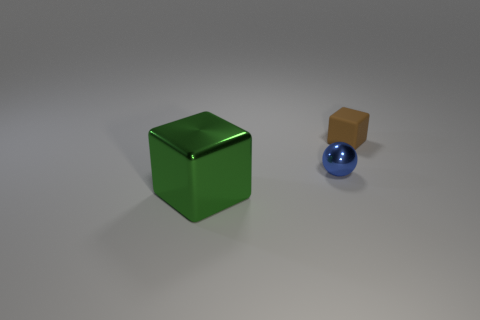Add 2 small brown cylinders. How many objects exist? 5 Subtract all balls. How many objects are left? 2 Subtract all large brown metal cubes. Subtract all brown matte blocks. How many objects are left? 2 Add 2 small brown cubes. How many small brown cubes are left? 3 Add 1 red rubber cylinders. How many red rubber cylinders exist? 1 Subtract 0 yellow balls. How many objects are left? 3 